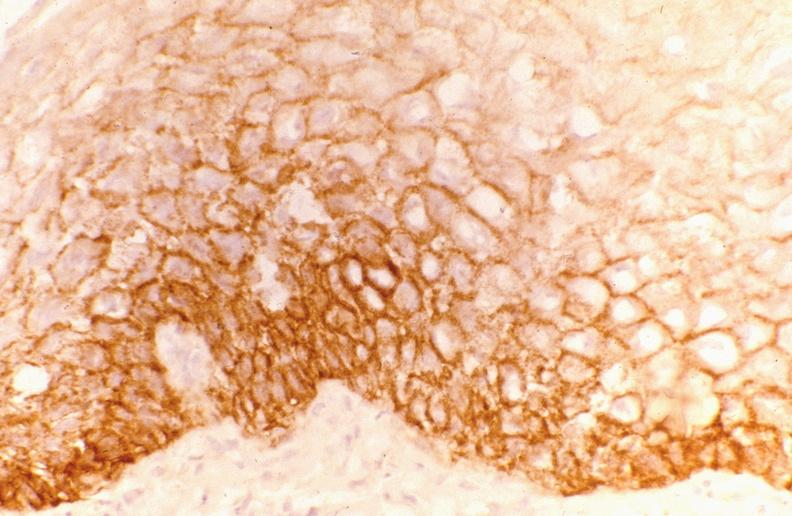s gastrointestinal present?
Answer the question using a single word or phrase. Yes 